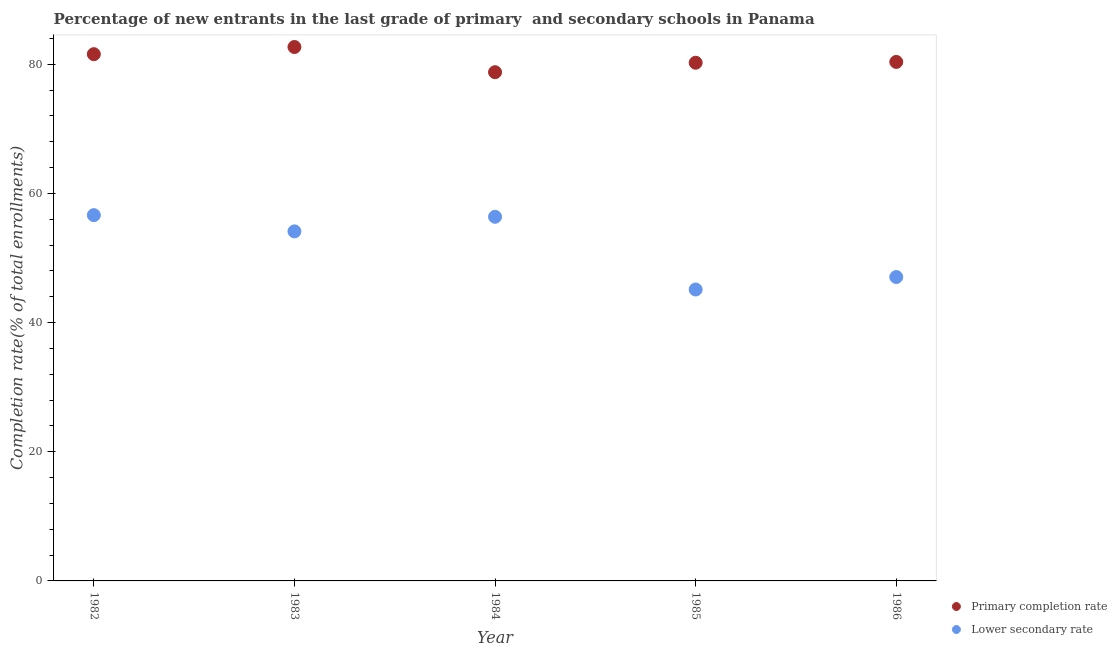What is the completion rate in primary schools in 1983?
Your answer should be compact. 82.69. Across all years, what is the maximum completion rate in primary schools?
Offer a terse response. 82.69. Across all years, what is the minimum completion rate in primary schools?
Offer a terse response. 78.78. In which year was the completion rate in secondary schools maximum?
Offer a very short reply. 1982. What is the total completion rate in secondary schools in the graph?
Offer a very short reply. 259.36. What is the difference between the completion rate in primary schools in 1982 and that in 1986?
Provide a short and direct response. 1.2. What is the difference between the completion rate in secondary schools in 1983 and the completion rate in primary schools in 1984?
Provide a short and direct response. -24.65. What is the average completion rate in primary schools per year?
Ensure brevity in your answer.  80.73. In the year 1986, what is the difference between the completion rate in secondary schools and completion rate in primary schools?
Give a very brief answer. -33.31. What is the ratio of the completion rate in secondary schools in 1984 to that in 1986?
Provide a short and direct response. 1.2. Is the difference between the completion rate in primary schools in 1984 and 1986 greater than the difference between the completion rate in secondary schools in 1984 and 1986?
Provide a short and direct response. No. What is the difference between the highest and the second highest completion rate in secondary schools?
Your answer should be compact. 0.25. What is the difference between the highest and the lowest completion rate in primary schools?
Make the answer very short. 3.9. How many dotlines are there?
Offer a terse response. 2. How many years are there in the graph?
Your answer should be very brief. 5. Are the values on the major ticks of Y-axis written in scientific E-notation?
Ensure brevity in your answer.  No. Does the graph contain any zero values?
Give a very brief answer. No. What is the title of the graph?
Give a very brief answer. Percentage of new entrants in the last grade of primary  and secondary schools in Panama. What is the label or title of the X-axis?
Provide a succinct answer. Year. What is the label or title of the Y-axis?
Your answer should be compact. Completion rate(% of total enrollments). What is the Completion rate(% of total enrollments) of Primary completion rate in 1982?
Give a very brief answer. 81.57. What is the Completion rate(% of total enrollments) in Lower secondary rate in 1982?
Your response must be concise. 56.64. What is the Completion rate(% of total enrollments) of Primary completion rate in 1983?
Offer a very short reply. 82.69. What is the Completion rate(% of total enrollments) of Lower secondary rate in 1983?
Offer a very short reply. 54.13. What is the Completion rate(% of total enrollments) of Primary completion rate in 1984?
Provide a short and direct response. 78.78. What is the Completion rate(% of total enrollments) of Lower secondary rate in 1984?
Provide a short and direct response. 56.39. What is the Completion rate(% of total enrollments) in Primary completion rate in 1985?
Keep it short and to the point. 80.25. What is the Completion rate(% of total enrollments) of Lower secondary rate in 1985?
Offer a very short reply. 45.13. What is the Completion rate(% of total enrollments) in Primary completion rate in 1986?
Make the answer very short. 80.37. What is the Completion rate(% of total enrollments) of Lower secondary rate in 1986?
Your answer should be compact. 47.06. Across all years, what is the maximum Completion rate(% of total enrollments) of Primary completion rate?
Offer a very short reply. 82.69. Across all years, what is the maximum Completion rate(% of total enrollments) in Lower secondary rate?
Provide a succinct answer. 56.64. Across all years, what is the minimum Completion rate(% of total enrollments) of Primary completion rate?
Ensure brevity in your answer.  78.78. Across all years, what is the minimum Completion rate(% of total enrollments) in Lower secondary rate?
Keep it short and to the point. 45.13. What is the total Completion rate(% of total enrollments) of Primary completion rate in the graph?
Provide a succinct answer. 403.66. What is the total Completion rate(% of total enrollments) in Lower secondary rate in the graph?
Offer a terse response. 259.36. What is the difference between the Completion rate(% of total enrollments) in Primary completion rate in 1982 and that in 1983?
Your response must be concise. -1.11. What is the difference between the Completion rate(% of total enrollments) of Lower secondary rate in 1982 and that in 1983?
Give a very brief answer. 2.51. What is the difference between the Completion rate(% of total enrollments) in Primary completion rate in 1982 and that in 1984?
Ensure brevity in your answer.  2.79. What is the difference between the Completion rate(% of total enrollments) of Lower secondary rate in 1982 and that in 1984?
Offer a very short reply. 0.25. What is the difference between the Completion rate(% of total enrollments) of Primary completion rate in 1982 and that in 1985?
Your answer should be compact. 1.33. What is the difference between the Completion rate(% of total enrollments) in Lower secondary rate in 1982 and that in 1985?
Offer a very short reply. 11.52. What is the difference between the Completion rate(% of total enrollments) in Primary completion rate in 1982 and that in 1986?
Ensure brevity in your answer.  1.2. What is the difference between the Completion rate(% of total enrollments) of Lower secondary rate in 1982 and that in 1986?
Make the answer very short. 9.58. What is the difference between the Completion rate(% of total enrollments) in Primary completion rate in 1983 and that in 1984?
Provide a short and direct response. 3.9. What is the difference between the Completion rate(% of total enrollments) in Lower secondary rate in 1983 and that in 1984?
Your response must be concise. -2.26. What is the difference between the Completion rate(% of total enrollments) of Primary completion rate in 1983 and that in 1985?
Keep it short and to the point. 2.44. What is the difference between the Completion rate(% of total enrollments) in Lower secondary rate in 1983 and that in 1985?
Ensure brevity in your answer.  9. What is the difference between the Completion rate(% of total enrollments) in Primary completion rate in 1983 and that in 1986?
Your answer should be compact. 2.31. What is the difference between the Completion rate(% of total enrollments) in Lower secondary rate in 1983 and that in 1986?
Your answer should be compact. 7.07. What is the difference between the Completion rate(% of total enrollments) in Primary completion rate in 1984 and that in 1985?
Keep it short and to the point. -1.46. What is the difference between the Completion rate(% of total enrollments) in Lower secondary rate in 1984 and that in 1985?
Keep it short and to the point. 11.26. What is the difference between the Completion rate(% of total enrollments) of Primary completion rate in 1984 and that in 1986?
Ensure brevity in your answer.  -1.59. What is the difference between the Completion rate(% of total enrollments) in Lower secondary rate in 1984 and that in 1986?
Keep it short and to the point. 9.33. What is the difference between the Completion rate(% of total enrollments) of Primary completion rate in 1985 and that in 1986?
Ensure brevity in your answer.  -0.13. What is the difference between the Completion rate(% of total enrollments) in Lower secondary rate in 1985 and that in 1986?
Make the answer very short. -1.93. What is the difference between the Completion rate(% of total enrollments) in Primary completion rate in 1982 and the Completion rate(% of total enrollments) in Lower secondary rate in 1983?
Offer a terse response. 27.44. What is the difference between the Completion rate(% of total enrollments) in Primary completion rate in 1982 and the Completion rate(% of total enrollments) in Lower secondary rate in 1984?
Make the answer very short. 25.18. What is the difference between the Completion rate(% of total enrollments) in Primary completion rate in 1982 and the Completion rate(% of total enrollments) in Lower secondary rate in 1985?
Ensure brevity in your answer.  36.44. What is the difference between the Completion rate(% of total enrollments) of Primary completion rate in 1982 and the Completion rate(% of total enrollments) of Lower secondary rate in 1986?
Offer a terse response. 34.51. What is the difference between the Completion rate(% of total enrollments) in Primary completion rate in 1983 and the Completion rate(% of total enrollments) in Lower secondary rate in 1984?
Offer a very short reply. 26.29. What is the difference between the Completion rate(% of total enrollments) of Primary completion rate in 1983 and the Completion rate(% of total enrollments) of Lower secondary rate in 1985?
Offer a terse response. 37.56. What is the difference between the Completion rate(% of total enrollments) in Primary completion rate in 1983 and the Completion rate(% of total enrollments) in Lower secondary rate in 1986?
Keep it short and to the point. 35.62. What is the difference between the Completion rate(% of total enrollments) of Primary completion rate in 1984 and the Completion rate(% of total enrollments) of Lower secondary rate in 1985?
Your answer should be compact. 33.65. What is the difference between the Completion rate(% of total enrollments) of Primary completion rate in 1984 and the Completion rate(% of total enrollments) of Lower secondary rate in 1986?
Ensure brevity in your answer.  31.72. What is the difference between the Completion rate(% of total enrollments) in Primary completion rate in 1985 and the Completion rate(% of total enrollments) in Lower secondary rate in 1986?
Your answer should be compact. 33.18. What is the average Completion rate(% of total enrollments) in Primary completion rate per year?
Keep it short and to the point. 80.73. What is the average Completion rate(% of total enrollments) in Lower secondary rate per year?
Ensure brevity in your answer.  51.87. In the year 1982, what is the difference between the Completion rate(% of total enrollments) of Primary completion rate and Completion rate(% of total enrollments) of Lower secondary rate?
Your response must be concise. 24.93. In the year 1983, what is the difference between the Completion rate(% of total enrollments) in Primary completion rate and Completion rate(% of total enrollments) in Lower secondary rate?
Provide a short and direct response. 28.55. In the year 1984, what is the difference between the Completion rate(% of total enrollments) of Primary completion rate and Completion rate(% of total enrollments) of Lower secondary rate?
Your answer should be very brief. 22.39. In the year 1985, what is the difference between the Completion rate(% of total enrollments) of Primary completion rate and Completion rate(% of total enrollments) of Lower secondary rate?
Give a very brief answer. 35.12. In the year 1986, what is the difference between the Completion rate(% of total enrollments) in Primary completion rate and Completion rate(% of total enrollments) in Lower secondary rate?
Offer a terse response. 33.31. What is the ratio of the Completion rate(% of total enrollments) of Primary completion rate in 1982 to that in 1983?
Your answer should be compact. 0.99. What is the ratio of the Completion rate(% of total enrollments) in Lower secondary rate in 1982 to that in 1983?
Ensure brevity in your answer.  1.05. What is the ratio of the Completion rate(% of total enrollments) of Primary completion rate in 1982 to that in 1984?
Keep it short and to the point. 1.04. What is the ratio of the Completion rate(% of total enrollments) in Lower secondary rate in 1982 to that in 1984?
Provide a succinct answer. 1. What is the ratio of the Completion rate(% of total enrollments) of Primary completion rate in 1982 to that in 1985?
Offer a very short reply. 1.02. What is the ratio of the Completion rate(% of total enrollments) of Lower secondary rate in 1982 to that in 1985?
Make the answer very short. 1.26. What is the ratio of the Completion rate(% of total enrollments) of Primary completion rate in 1982 to that in 1986?
Your answer should be very brief. 1.01. What is the ratio of the Completion rate(% of total enrollments) in Lower secondary rate in 1982 to that in 1986?
Make the answer very short. 1.2. What is the ratio of the Completion rate(% of total enrollments) of Primary completion rate in 1983 to that in 1984?
Give a very brief answer. 1.05. What is the ratio of the Completion rate(% of total enrollments) of Lower secondary rate in 1983 to that in 1984?
Provide a succinct answer. 0.96. What is the ratio of the Completion rate(% of total enrollments) in Primary completion rate in 1983 to that in 1985?
Provide a succinct answer. 1.03. What is the ratio of the Completion rate(% of total enrollments) of Lower secondary rate in 1983 to that in 1985?
Offer a terse response. 1.2. What is the ratio of the Completion rate(% of total enrollments) in Primary completion rate in 1983 to that in 1986?
Ensure brevity in your answer.  1.03. What is the ratio of the Completion rate(% of total enrollments) in Lower secondary rate in 1983 to that in 1986?
Provide a succinct answer. 1.15. What is the ratio of the Completion rate(% of total enrollments) in Primary completion rate in 1984 to that in 1985?
Your answer should be compact. 0.98. What is the ratio of the Completion rate(% of total enrollments) of Lower secondary rate in 1984 to that in 1985?
Give a very brief answer. 1.25. What is the ratio of the Completion rate(% of total enrollments) of Primary completion rate in 1984 to that in 1986?
Your answer should be compact. 0.98. What is the ratio of the Completion rate(% of total enrollments) of Lower secondary rate in 1984 to that in 1986?
Offer a terse response. 1.2. What is the ratio of the Completion rate(% of total enrollments) in Primary completion rate in 1985 to that in 1986?
Provide a short and direct response. 1. What is the ratio of the Completion rate(% of total enrollments) in Lower secondary rate in 1985 to that in 1986?
Give a very brief answer. 0.96. What is the difference between the highest and the second highest Completion rate(% of total enrollments) of Primary completion rate?
Keep it short and to the point. 1.11. What is the difference between the highest and the second highest Completion rate(% of total enrollments) in Lower secondary rate?
Your response must be concise. 0.25. What is the difference between the highest and the lowest Completion rate(% of total enrollments) of Primary completion rate?
Your response must be concise. 3.9. What is the difference between the highest and the lowest Completion rate(% of total enrollments) of Lower secondary rate?
Provide a short and direct response. 11.52. 